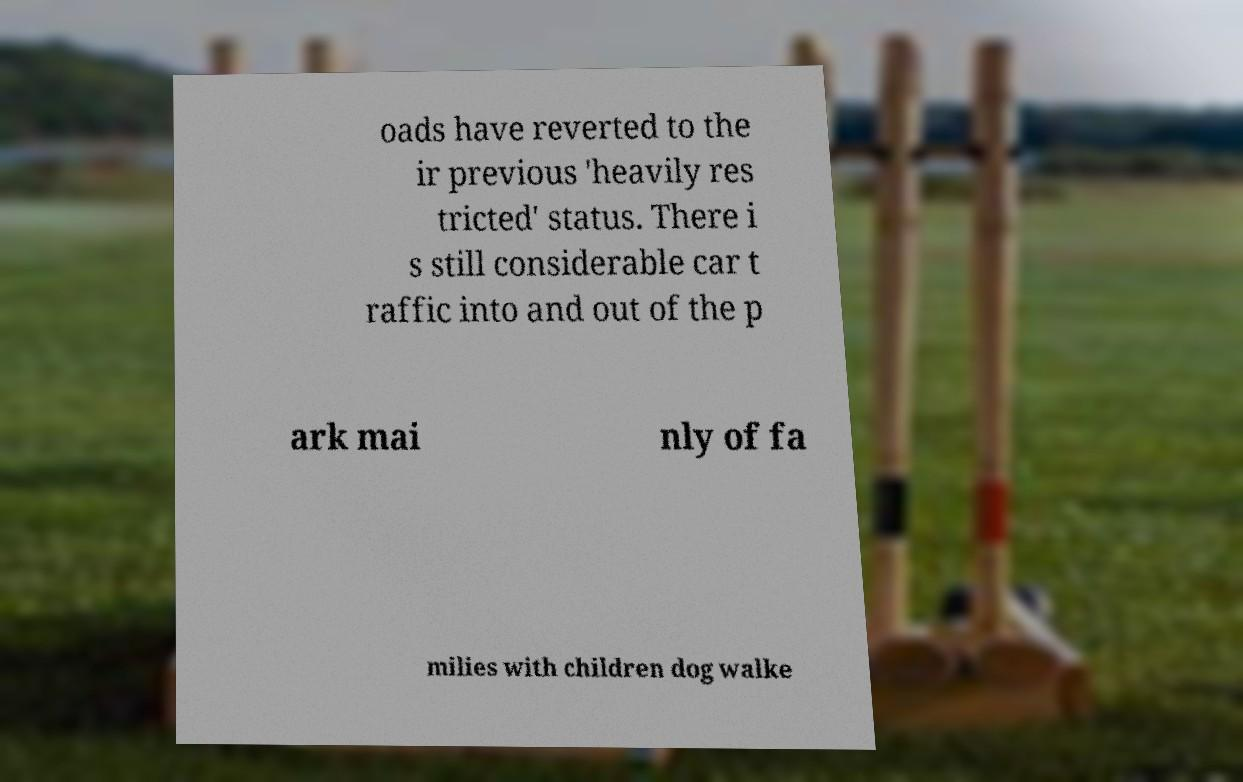Please identify and transcribe the text found in this image. oads have reverted to the ir previous 'heavily res tricted' status. There i s still considerable car t raffic into and out of the p ark mai nly of fa milies with children dog walke 